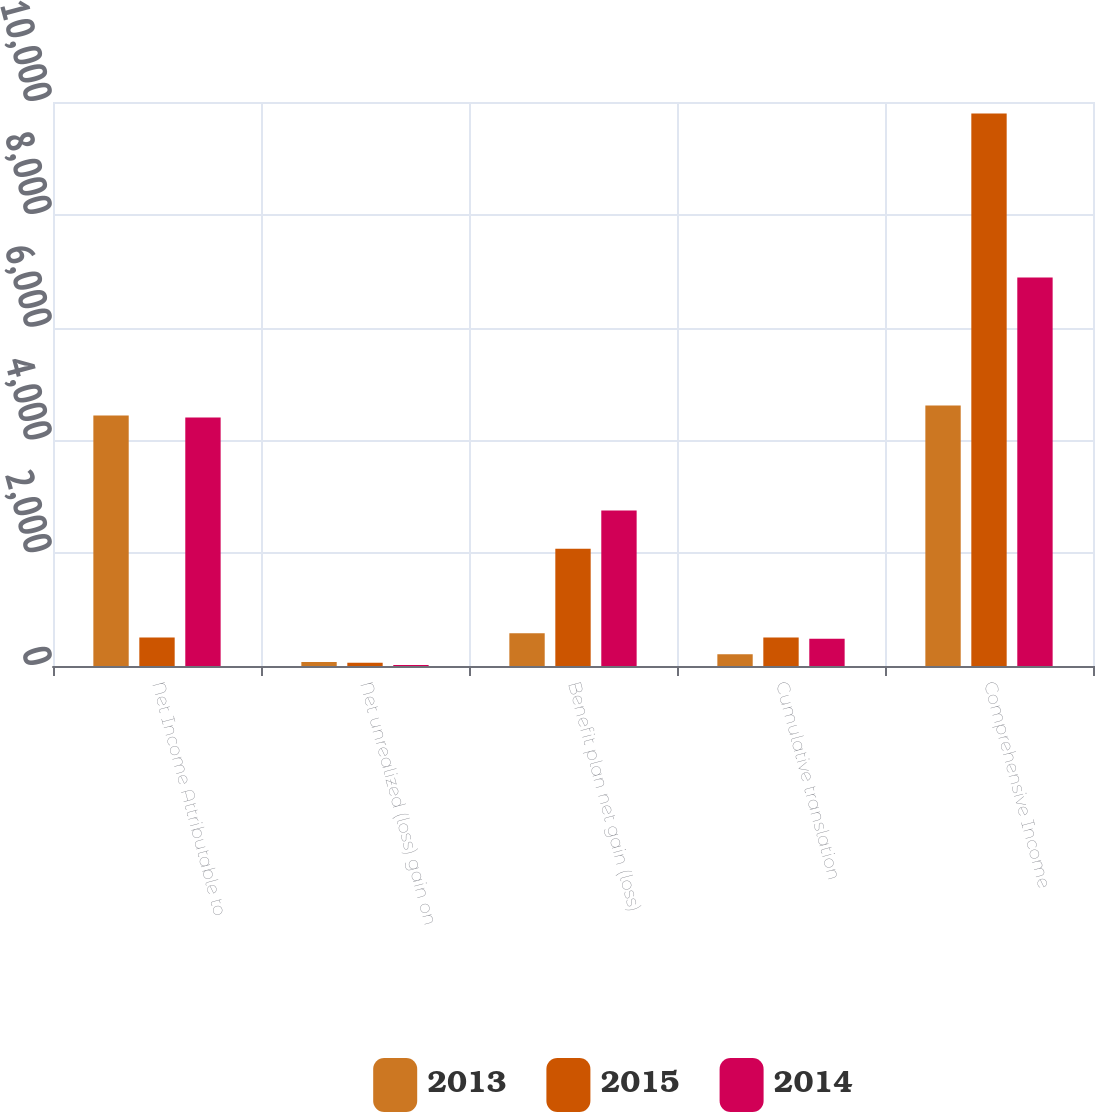Convert chart to OTSL. <chart><loc_0><loc_0><loc_500><loc_500><stacked_bar_chart><ecel><fcel>Net Income Attributable to<fcel>Net unrealized (loss) gain on<fcel>Benefit plan net gain (loss)<fcel>Cumulative translation<fcel>Comprehensive Income<nl><fcel>2013<fcel>4442<fcel>70<fcel>579<fcel>208<fcel>4617<nl><fcel>2015<fcel>504<fcel>57<fcel>2077<fcel>504<fcel>9794<nl><fcel>2014<fcel>4404<fcel>19<fcel>2758<fcel>483<fcel>6889<nl></chart> 